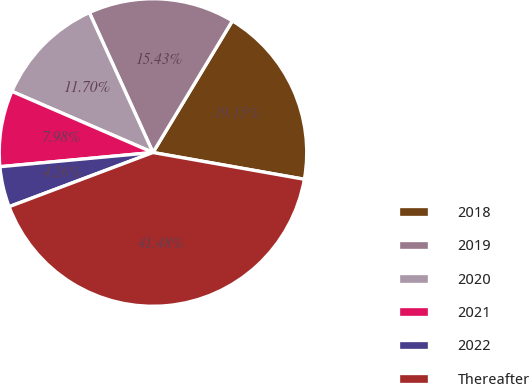Convert chart. <chart><loc_0><loc_0><loc_500><loc_500><pie_chart><fcel>2018<fcel>2019<fcel>2020<fcel>2021<fcel>2022<fcel>Thereafter<nl><fcel>19.15%<fcel>15.43%<fcel>11.7%<fcel>7.98%<fcel>4.26%<fcel>41.48%<nl></chart> 